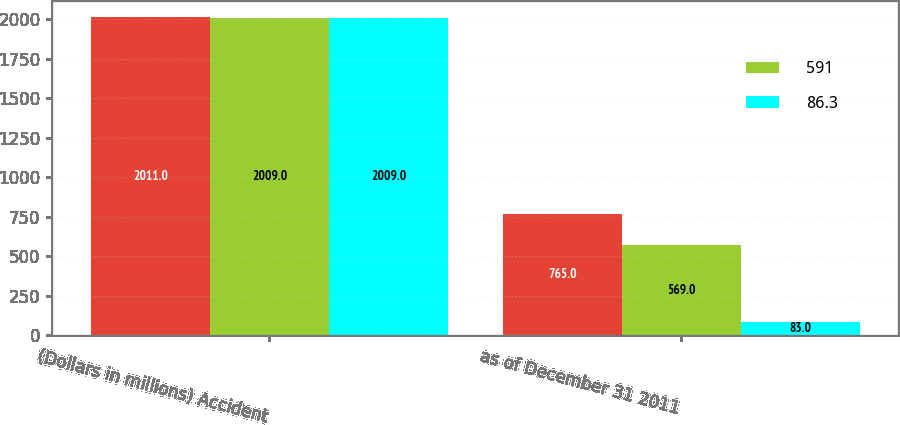Convert chart to OTSL. <chart><loc_0><loc_0><loc_500><loc_500><stacked_bar_chart><ecel><fcel>(Dollars in millions) Accident<fcel>as of December 31 2011<nl><fcel>nan<fcel>2011<fcel>765<nl><fcel>591<fcel>2009<fcel>569<nl><fcel>86.3<fcel>2009<fcel>83<nl></chart> 